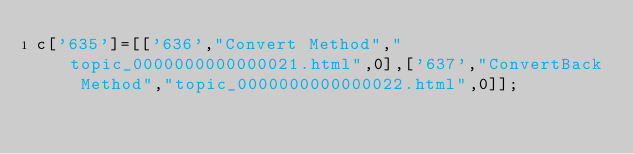Convert code to text. <code><loc_0><loc_0><loc_500><loc_500><_JavaScript_>c['635']=[['636',"Convert Method","topic_0000000000000021.html",0],['637',"ConvertBack Method","topic_0000000000000022.html",0]];</code> 